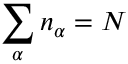Convert formula to latex. <formula><loc_0><loc_0><loc_500><loc_500>\sum _ { \alpha } n _ { \alpha } = N</formula> 